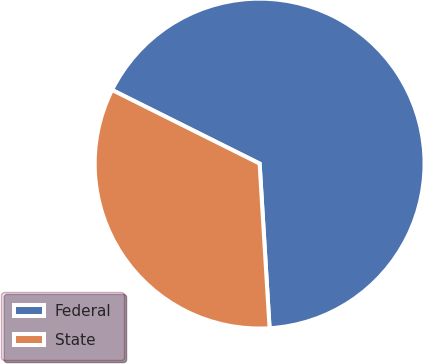Convert chart to OTSL. <chart><loc_0><loc_0><loc_500><loc_500><pie_chart><fcel>Federal<fcel>State<nl><fcel>66.67%<fcel>33.33%<nl></chart> 